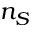Convert formula to latex. <formula><loc_0><loc_0><loc_500><loc_500>n _ { S }</formula> 